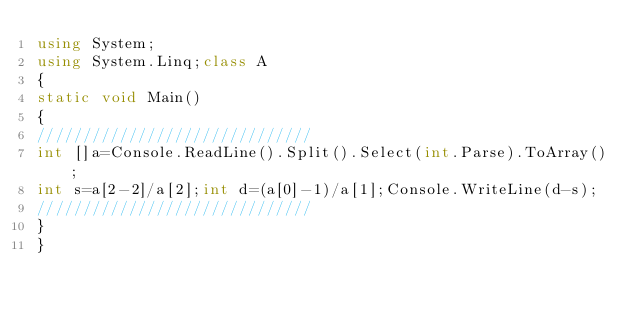<code> <loc_0><loc_0><loc_500><loc_500><_C#_>using System;
using System.Linq;class A
{
static void Main()
{
//////////////////////////////
int []a=Console.ReadLine().Split().Select(int.Parse).ToArray();
int s=a[2-2]/a[2];int d=(a[0]-1)/a[1];Console.WriteLine(d-s);
//////////////////////////////
}
}</code> 